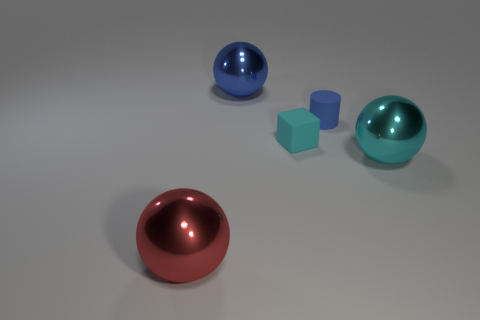Add 4 large gray metal spheres. How many objects exist? 9 Subtract all red metallic spheres. How many spheres are left? 2 Add 2 large cyan metallic spheres. How many large cyan metallic spheres exist? 3 Subtract 0 brown cylinders. How many objects are left? 5 Subtract all cylinders. How many objects are left? 4 Subtract all blue cylinders. Subtract all big purple balls. How many objects are left? 4 Add 4 shiny spheres. How many shiny spheres are left? 7 